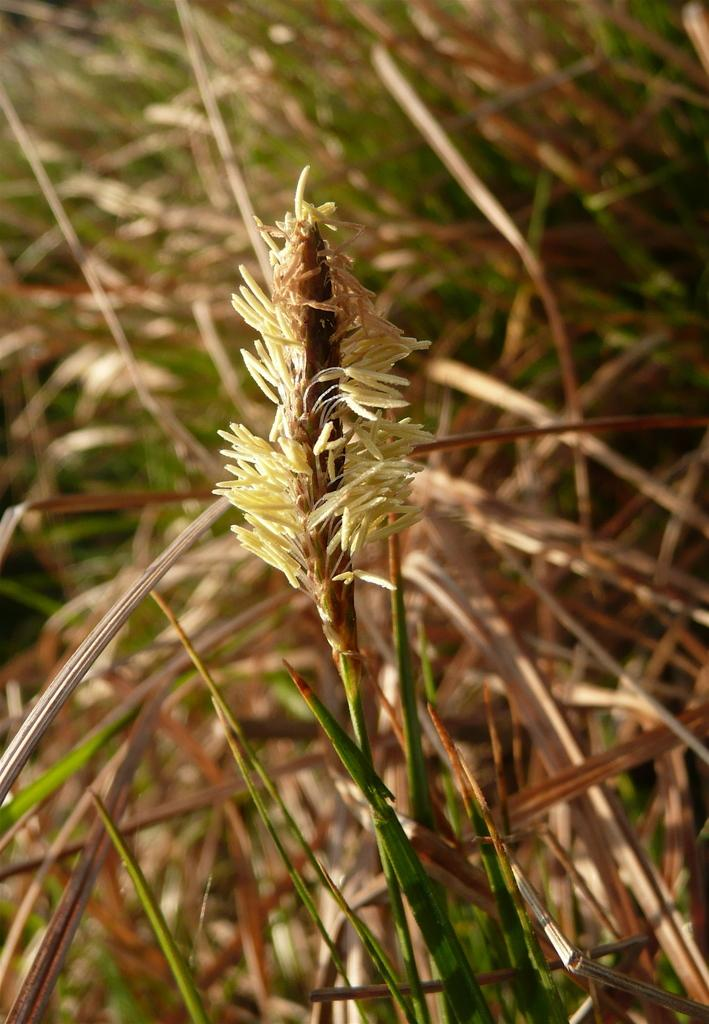What type of living organisms can be seen in the image? Plants can be seen in the image. Can you describe the background of the image? The background of the image is blurred. What type of headwear is the porter wearing in the image? There is no porter present in the image, and therefore no headwear can be observed. What type of mine is visible in the image? There is no mine present in the image. 